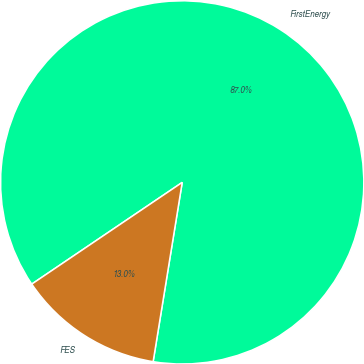Convert chart. <chart><loc_0><loc_0><loc_500><loc_500><pie_chart><fcel>FirstEnergy<fcel>FES<nl><fcel>87.02%<fcel>12.98%<nl></chart> 